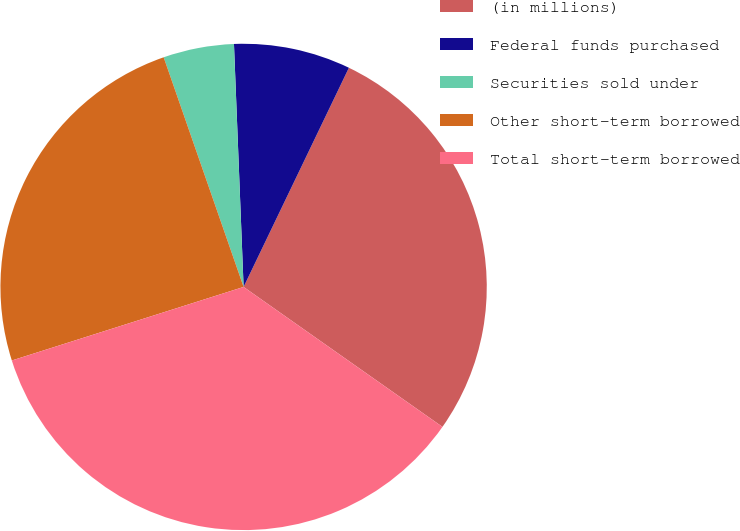Convert chart. <chart><loc_0><loc_0><loc_500><loc_500><pie_chart><fcel>(in millions)<fcel>Federal funds purchased<fcel>Securities sold under<fcel>Other short-term borrowed<fcel>Total short-term borrowed<nl><fcel>27.63%<fcel>7.76%<fcel>4.7%<fcel>24.56%<fcel>35.35%<nl></chart> 